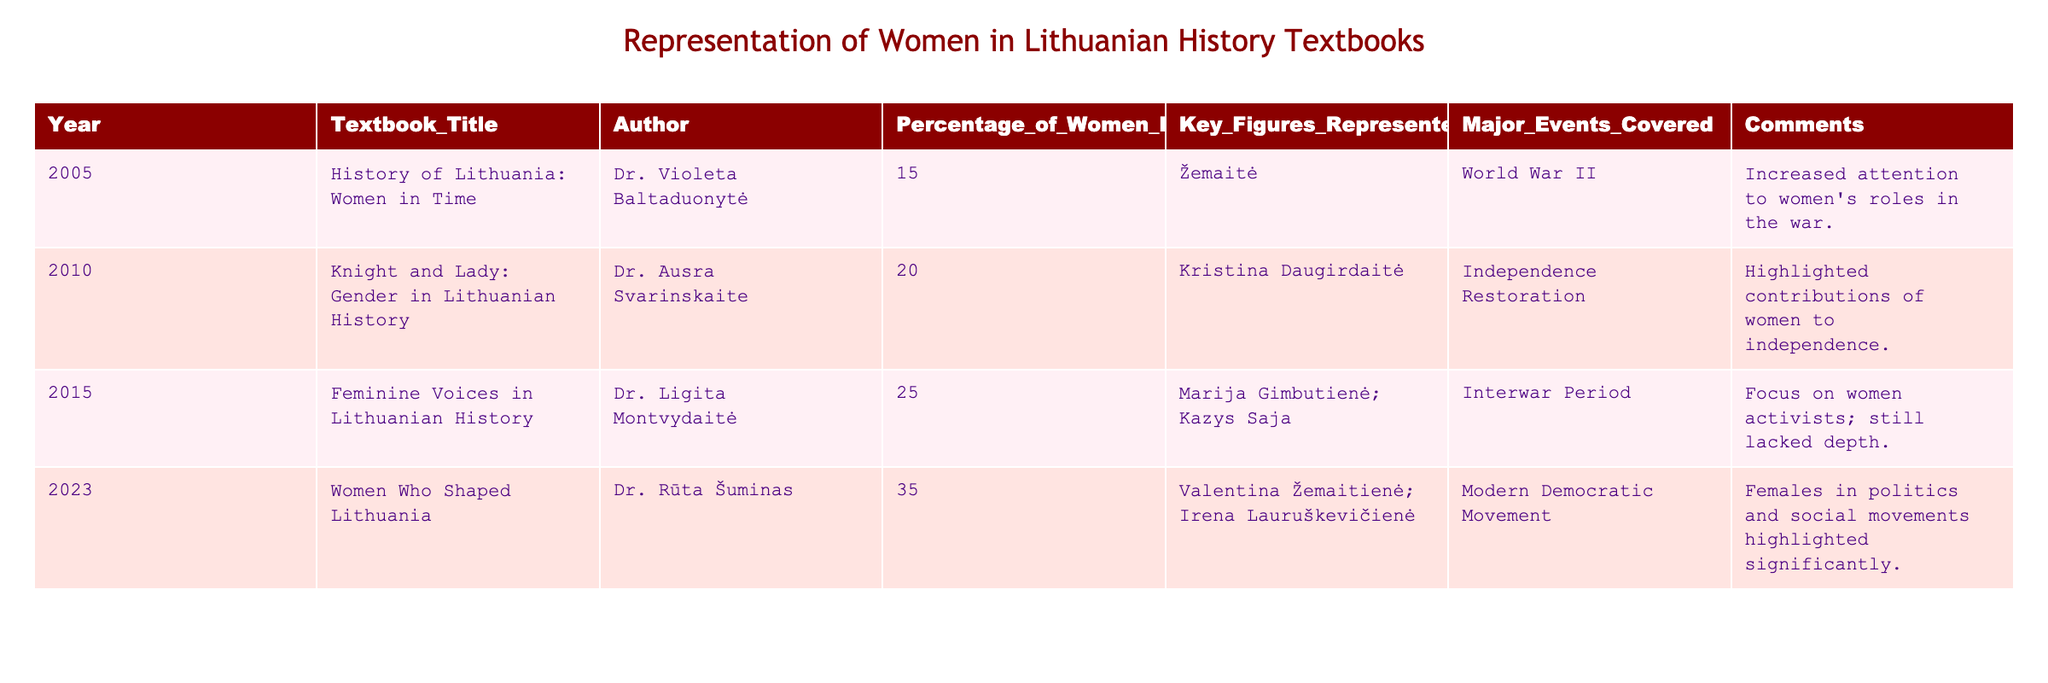What is the year of the textbook with the highest percentage of women historical figures? The table shows that in 2023, "Women Who Shaped Lithuania" has the highest percentage of women historical figures at 35%.
Answer: 2023 Which historical figure is mentioned in the 2015 textbook? The 2015 textbook "Feminine Voices in Lithuanian History" mentions Marija Gimbutienė and Kazys Saja as key figures represented.
Answer: Marija Gimbutienė; Kazys Saja What was the percentage of women historical figures in the 2010 textbook? The 2010 textbook "Knight and Lady: Gender in Lithuanian History" has a percentage of 20% regarding women historical figures.
Answer: 20% Is there a textbook that focuses on the Interwar Period? Yes, the 2015 textbook "Feminine Voices in Lithuanian History" covers the Interwar Period.
Answer: Yes How many textbooks have a percentage of women historical figures greater than 20? There are two textbooks with a percentage greater than 20%: the 2015 (25%) and 2023 (35%) textbooks.
Answer: 2 What is the difference in the percentage of women historical figures between the 2005 and 2023 textbooks? The percentage in 2005 is 15% and in 2023 is 35%. The difference is 35 - 15 = 20%.
Answer: 20% Which textbook highlighted contributions of women to independence? The textbook titled "Knight and Lady: Gender in Lithuanian History" published in 2010 highlighted contributions of women to independence.
Answer: Knight and Lady: Gender in Lithuanian History If you average the percentage of women historical figures from all four textbooks, what do you get? First, sum the percentages: 15 + 20 + 25 + 35 = 95. There are 4 textbooks, so the average is 95 / 4 = 23.75%.
Answer: 23.75% Which year saw a notable increase in the representation of women? There was a notable increase from 15% in 2005 to 35% in 2023, which represents a significant increase.
Answer: 2023 Are there any textbooks that discuss women's roles during World War II? Yes, the 2005 textbook "History of Lithuania: Women in Time" increased attention to women's roles during World War II.
Answer: Yes 